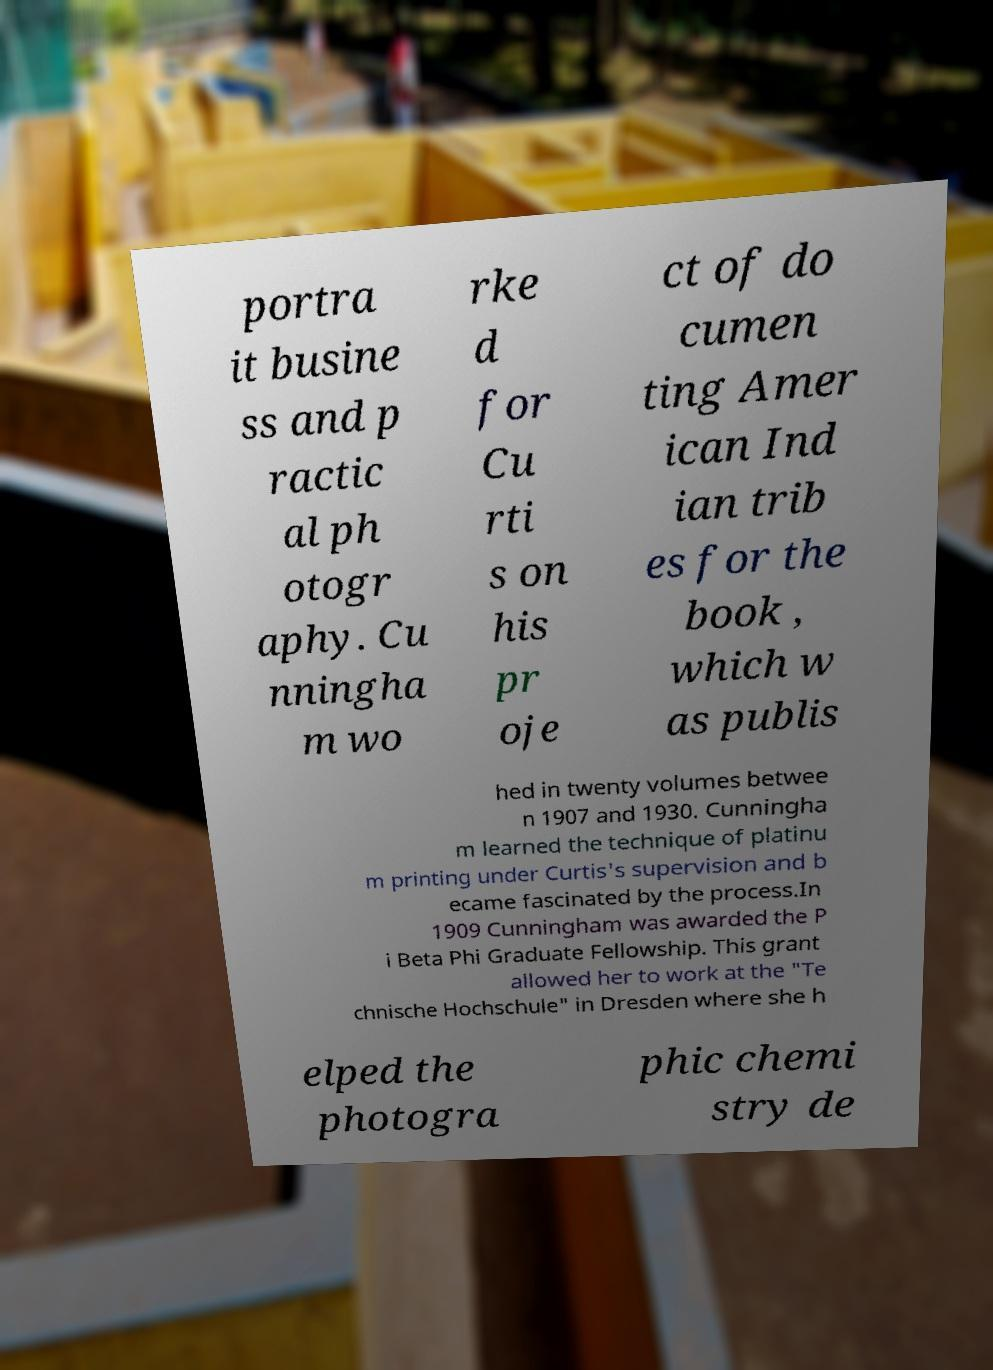Please identify and transcribe the text found in this image. portra it busine ss and p ractic al ph otogr aphy. Cu nningha m wo rke d for Cu rti s on his pr oje ct of do cumen ting Amer ican Ind ian trib es for the book , which w as publis hed in twenty volumes betwee n 1907 and 1930. Cunningha m learned the technique of platinu m printing under Curtis's supervision and b ecame fascinated by the process.In 1909 Cunningham was awarded the P i Beta Phi Graduate Fellowship. This grant allowed her to work at the "Te chnische Hochschule" in Dresden where she h elped the photogra phic chemi stry de 